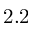<formula> <loc_0><loc_0><loc_500><loc_500>2 . 2</formula> 